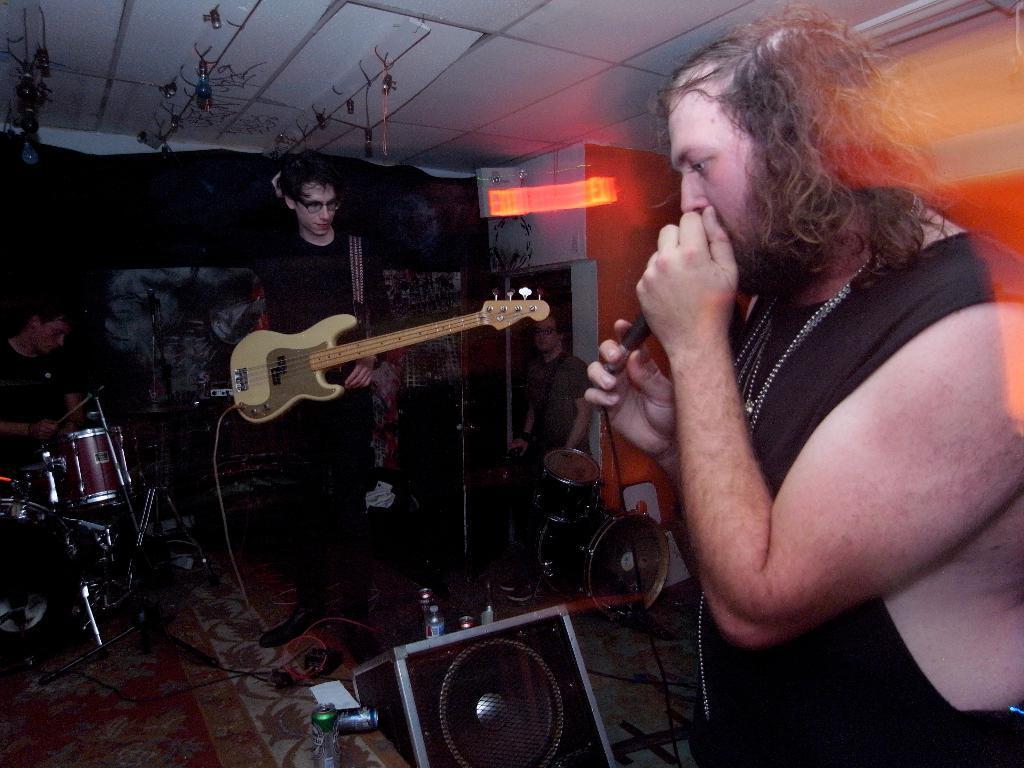Please provide a concise description of this image. In this image I can see four people and these people are playing the musical instruments. 